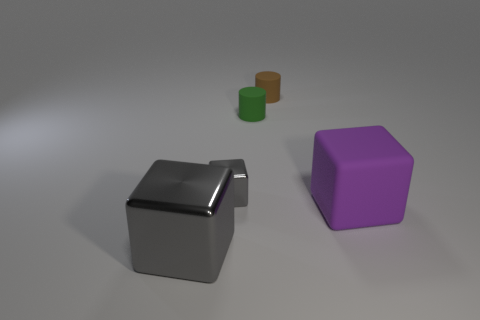Subtract all yellow cylinders. How many gray blocks are left? 2 Subtract all small shiny blocks. How many blocks are left? 2 Add 2 blue matte cylinders. How many objects exist? 7 Subtract all brown cubes. Subtract all red balls. How many cubes are left? 3 Subtract 1 brown cylinders. How many objects are left? 4 Subtract all cylinders. How many objects are left? 3 Subtract all green cylinders. Subtract all big rubber cubes. How many objects are left? 3 Add 2 large things. How many large things are left? 4 Add 2 big purple rubber things. How many big purple rubber things exist? 3 